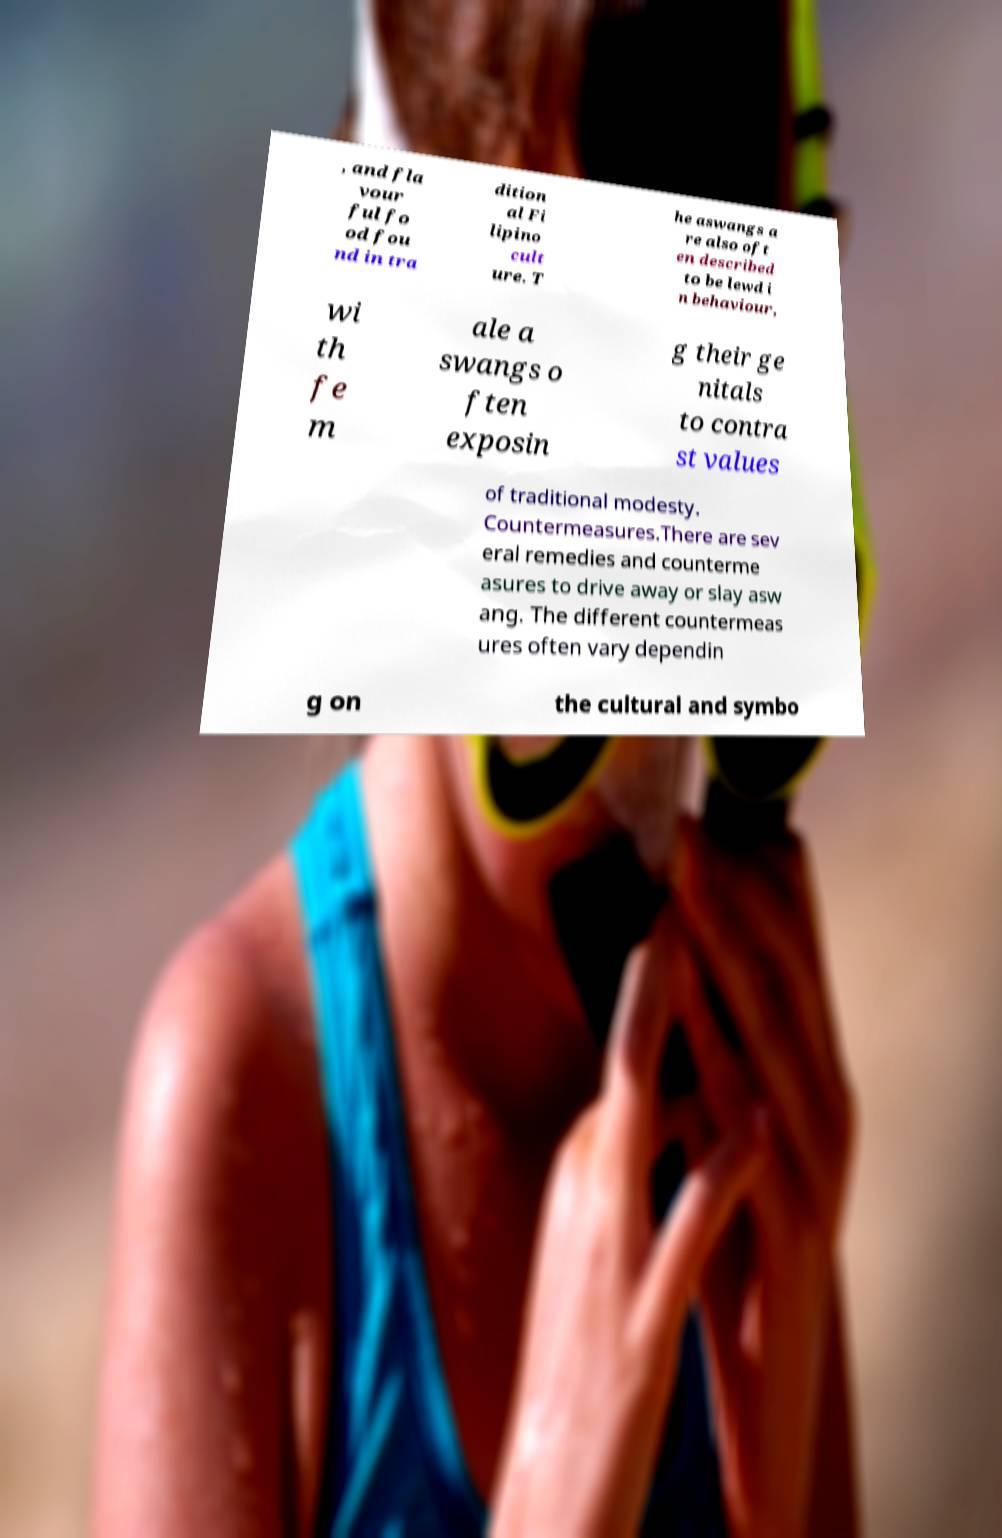For documentation purposes, I need the text within this image transcribed. Could you provide that? , and fla vour ful fo od fou nd in tra dition al Fi lipino cult ure. T he aswangs a re also oft en described to be lewd i n behaviour, wi th fe m ale a swangs o ften exposin g their ge nitals to contra st values of traditional modesty. Countermeasures.There are sev eral remedies and counterme asures to drive away or slay asw ang. The different countermeas ures often vary dependin g on the cultural and symbo 